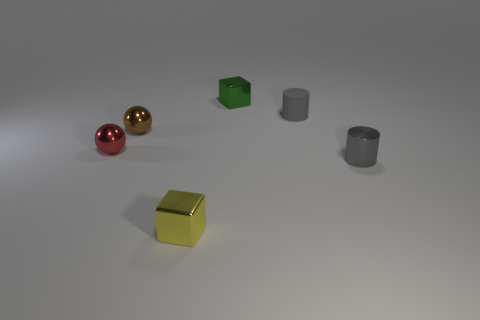Add 1 gray rubber things. How many objects exist? 7 Subtract all brown spheres. How many spheres are left? 1 Subtract all red balls. Subtract all green blocks. How many objects are left? 4 Add 4 yellow blocks. How many yellow blocks are left? 5 Add 3 green matte cylinders. How many green matte cylinders exist? 3 Subtract 0 red blocks. How many objects are left? 6 Subtract 1 balls. How many balls are left? 1 Subtract all red cylinders. Subtract all green balls. How many cylinders are left? 2 Subtract all brown cubes. How many purple cylinders are left? 0 